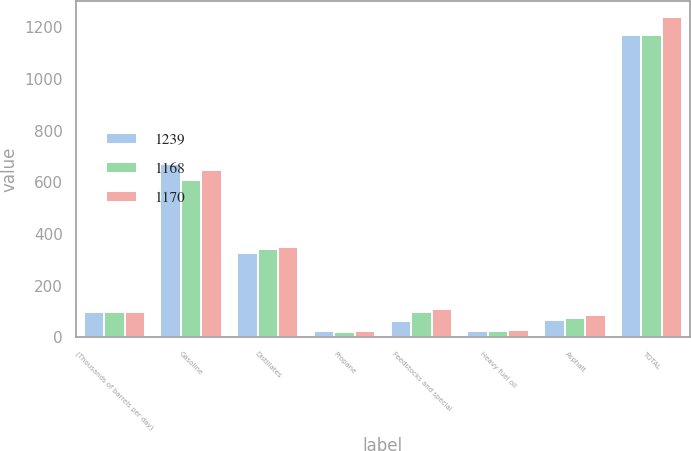Convert chart. <chart><loc_0><loc_0><loc_500><loc_500><stacked_bar_chart><ecel><fcel>(Thousands of barrels per day)<fcel>Gasoline<fcel>Distillates<fcel>Propane<fcel>Feedstocks and special<fcel>Heavy fuel oil<fcel>Asphalt<fcel>TOTAL<nl><fcel>1239<fcel>96<fcel>669<fcel>326<fcel>23<fcel>62<fcel>24<fcel>66<fcel>1170<nl><fcel>1168<fcel>96<fcel>609<fcel>342<fcel>22<fcel>96<fcel>24<fcel>75<fcel>1168<nl><fcel>1170<fcel>96<fcel>646<fcel>349<fcel>23<fcel>108<fcel>27<fcel>86<fcel>1239<nl></chart> 